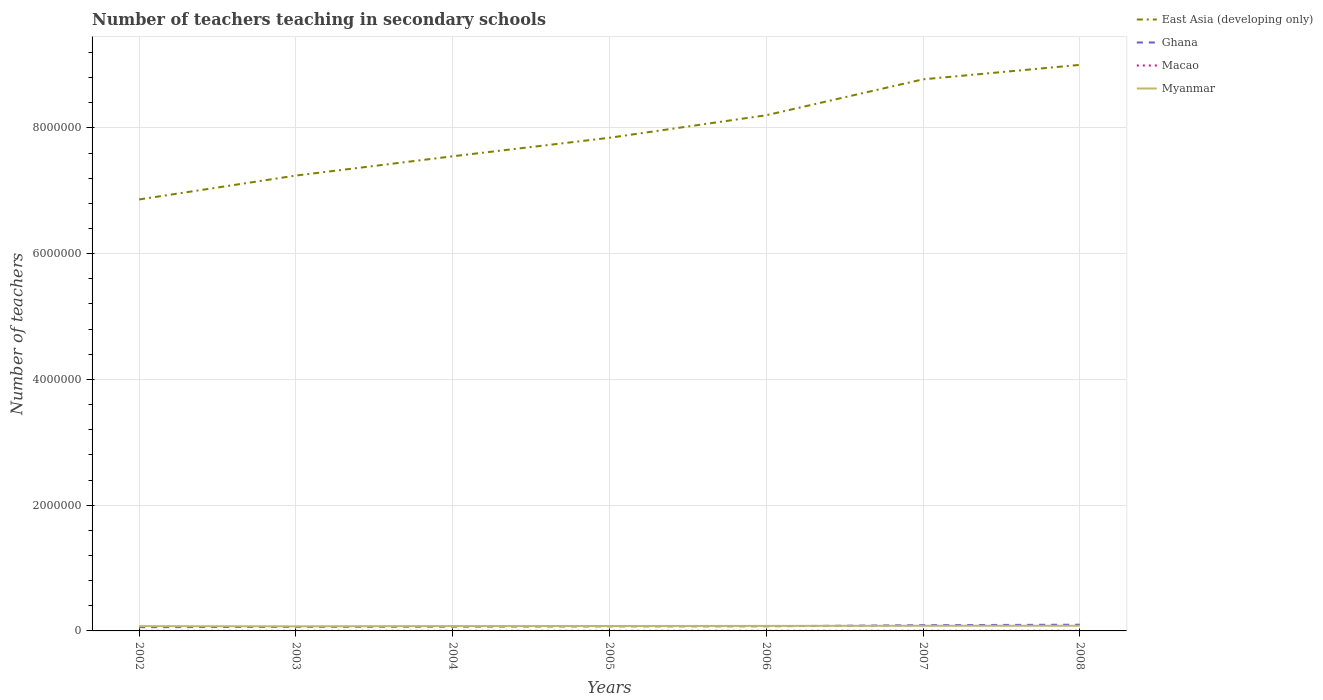Does the line corresponding to East Asia (developing only) intersect with the line corresponding to Myanmar?
Your answer should be compact. No. Is the number of lines equal to the number of legend labels?
Provide a short and direct response. Yes. Across all years, what is the maximum number of teachers teaching in secondary schools in Ghana?
Give a very brief answer. 5.94e+04. What is the total number of teachers teaching in secondary schools in East Asia (developing only) in the graph?
Provide a short and direct response. -8.01e+05. What is the difference between the highest and the second highest number of teachers teaching in secondary schools in Macao?
Offer a terse response. 457. What is the difference between the highest and the lowest number of teachers teaching in secondary schools in Macao?
Offer a very short reply. 4. Is the number of teachers teaching in secondary schools in Macao strictly greater than the number of teachers teaching in secondary schools in Myanmar over the years?
Ensure brevity in your answer.  Yes. How many lines are there?
Provide a short and direct response. 4. What is the difference between two consecutive major ticks on the Y-axis?
Make the answer very short. 2.00e+06. Does the graph contain grids?
Give a very brief answer. Yes. Where does the legend appear in the graph?
Your answer should be very brief. Top right. How many legend labels are there?
Your answer should be very brief. 4. What is the title of the graph?
Ensure brevity in your answer.  Number of teachers teaching in secondary schools. What is the label or title of the X-axis?
Your answer should be very brief. Years. What is the label or title of the Y-axis?
Offer a terse response. Number of teachers. What is the Number of teachers in East Asia (developing only) in 2002?
Your answer should be very brief. 6.86e+06. What is the Number of teachers in Ghana in 2002?
Offer a terse response. 5.94e+04. What is the Number of teachers of Macao in 2002?
Make the answer very short. 1753. What is the Number of teachers in Myanmar in 2002?
Offer a very short reply. 7.62e+04. What is the Number of teachers of East Asia (developing only) in 2003?
Provide a succinct answer. 7.24e+06. What is the Number of teachers in Ghana in 2003?
Keep it short and to the point. 6.44e+04. What is the Number of teachers in Macao in 2003?
Give a very brief answer. 1791. What is the Number of teachers in Myanmar in 2003?
Your answer should be very brief. 7.31e+04. What is the Number of teachers of East Asia (developing only) in 2004?
Make the answer very short. 7.55e+06. What is the Number of teachers of Ghana in 2004?
Ensure brevity in your answer.  6.79e+04. What is the Number of teachers in Macao in 2004?
Your answer should be very brief. 2001. What is the Number of teachers in Myanmar in 2004?
Your answer should be compact. 7.70e+04. What is the Number of teachers of East Asia (developing only) in 2005?
Keep it short and to the point. 7.84e+06. What is the Number of teachers of Ghana in 2005?
Your answer should be very brief. 7.25e+04. What is the Number of teachers of Macao in 2005?
Provide a succinct answer. 2077. What is the Number of teachers of Myanmar in 2005?
Make the answer very short. 7.81e+04. What is the Number of teachers of East Asia (developing only) in 2006?
Your response must be concise. 8.20e+06. What is the Number of teachers of Ghana in 2006?
Make the answer very short. 7.39e+04. What is the Number of teachers in Macao in 2006?
Provide a short and direct response. 2154. What is the Number of teachers in Myanmar in 2006?
Give a very brief answer. 7.98e+04. What is the Number of teachers of East Asia (developing only) in 2007?
Give a very brief answer. 8.77e+06. What is the Number of teachers in Ghana in 2007?
Make the answer very short. 9.15e+04. What is the Number of teachers of Macao in 2007?
Keep it short and to the point. 2210. What is the Number of teachers in Myanmar in 2007?
Your answer should be compact. 8.19e+04. What is the Number of teachers in East Asia (developing only) in 2008?
Provide a succinct answer. 9.00e+06. What is the Number of teachers in Ghana in 2008?
Offer a terse response. 9.90e+04. What is the Number of teachers in Macao in 2008?
Your answer should be compact. 2177. What is the Number of teachers of Myanmar in 2008?
Your answer should be very brief. 8.20e+04. Across all years, what is the maximum Number of teachers in East Asia (developing only)?
Make the answer very short. 9.00e+06. Across all years, what is the maximum Number of teachers of Ghana?
Your answer should be compact. 9.90e+04. Across all years, what is the maximum Number of teachers in Macao?
Offer a terse response. 2210. Across all years, what is the maximum Number of teachers in Myanmar?
Provide a short and direct response. 8.20e+04. Across all years, what is the minimum Number of teachers in East Asia (developing only)?
Your answer should be compact. 6.86e+06. Across all years, what is the minimum Number of teachers in Ghana?
Provide a succinct answer. 5.94e+04. Across all years, what is the minimum Number of teachers in Macao?
Provide a succinct answer. 1753. Across all years, what is the minimum Number of teachers of Myanmar?
Offer a terse response. 7.31e+04. What is the total Number of teachers of East Asia (developing only) in the graph?
Offer a terse response. 5.55e+07. What is the total Number of teachers in Ghana in the graph?
Provide a short and direct response. 5.29e+05. What is the total Number of teachers of Macao in the graph?
Provide a succinct answer. 1.42e+04. What is the total Number of teachers in Myanmar in the graph?
Offer a very short reply. 5.48e+05. What is the difference between the Number of teachers in East Asia (developing only) in 2002 and that in 2003?
Provide a short and direct response. -3.80e+05. What is the difference between the Number of teachers in Ghana in 2002 and that in 2003?
Your answer should be very brief. -4981. What is the difference between the Number of teachers in Macao in 2002 and that in 2003?
Provide a succinct answer. -38. What is the difference between the Number of teachers in Myanmar in 2002 and that in 2003?
Keep it short and to the point. 3088. What is the difference between the Number of teachers in East Asia (developing only) in 2002 and that in 2004?
Offer a very short reply. -6.86e+05. What is the difference between the Number of teachers of Ghana in 2002 and that in 2004?
Your answer should be compact. -8508. What is the difference between the Number of teachers in Macao in 2002 and that in 2004?
Offer a terse response. -248. What is the difference between the Number of teachers of Myanmar in 2002 and that in 2004?
Provide a succinct answer. -854. What is the difference between the Number of teachers in East Asia (developing only) in 2002 and that in 2005?
Provide a succinct answer. -9.81e+05. What is the difference between the Number of teachers of Ghana in 2002 and that in 2005?
Provide a succinct answer. -1.31e+04. What is the difference between the Number of teachers of Macao in 2002 and that in 2005?
Offer a terse response. -324. What is the difference between the Number of teachers of Myanmar in 2002 and that in 2005?
Provide a succinct answer. -1994. What is the difference between the Number of teachers of East Asia (developing only) in 2002 and that in 2006?
Your response must be concise. -1.34e+06. What is the difference between the Number of teachers in Ghana in 2002 and that in 2006?
Provide a short and direct response. -1.44e+04. What is the difference between the Number of teachers in Macao in 2002 and that in 2006?
Your response must be concise. -401. What is the difference between the Number of teachers in Myanmar in 2002 and that in 2006?
Provide a short and direct response. -3687. What is the difference between the Number of teachers of East Asia (developing only) in 2002 and that in 2007?
Your response must be concise. -1.91e+06. What is the difference between the Number of teachers in Ghana in 2002 and that in 2007?
Offer a terse response. -3.20e+04. What is the difference between the Number of teachers of Macao in 2002 and that in 2007?
Your answer should be very brief. -457. What is the difference between the Number of teachers of Myanmar in 2002 and that in 2007?
Provide a short and direct response. -5793. What is the difference between the Number of teachers of East Asia (developing only) in 2002 and that in 2008?
Ensure brevity in your answer.  -2.14e+06. What is the difference between the Number of teachers in Ghana in 2002 and that in 2008?
Your answer should be very brief. -3.96e+04. What is the difference between the Number of teachers of Macao in 2002 and that in 2008?
Ensure brevity in your answer.  -424. What is the difference between the Number of teachers in Myanmar in 2002 and that in 2008?
Your response must be concise. -5851. What is the difference between the Number of teachers in East Asia (developing only) in 2003 and that in 2004?
Offer a very short reply. -3.07e+05. What is the difference between the Number of teachers of Ghana in 2003 and that in 2004?
Keep it short and to the point. -3527. What is the difference between the Number of teachers of Macao in 2003 and that in 2004?
Keep it short and to the point. -210. What is the difference between the Number of teachers in Myanmar in 2003 and that in 2004?
Keep it short and to the point. -3942. What is the difference between the Number of teachers of East Asia (developing only) in 2003 and that in 2005?
Make the answer very short. -6.01e+05. What is the difference between the Number of teachers of Ghana in 2003 and that in 2005?
Your answer should be compact. -8083. What is the difference between the Number of teachers of Macao in 2003 and that in 2005?
Ensure brevity in your answer.  -286. What is the difference between the Number of teachers in Myanmar in 2003 and that in 2005?
Keep it short and to the point. -5082. What is the difference between the Number of teachers in East Asia (developing only) in 2003 and that in 2006?
Give a very brief answer. -9.59e+05. What is the difference between the Number of teachers in Ghana in 2003 and that in 2006?
Your response must be concise. -9447. What is the difference between the Number of teachers of Macao in 2003 and that in 2006?
Ensure brevity in your answer.  -363. What is the difference between the Number of teachers of Myanmar in 2003 and that in 2006?
Ensure brevity in your answer.  -6775. What is the difference between the Number of teachers in East Asia (developing only) in 2003 and that in 2007?
Make the answer very short. -1.53e+06. What is the difference between the Number of teachers of Ghana in 2003 and that in 2007?
Provide a succinct answer. -2.71e+04. What is the difference between the Number of teachers of Macao in 2003 and that in 2007?
Your answer should be very brief. -419. What is the difference between the Number of teachers in Myanmar in 2003 and that in 2007?
Make the answer very short. -8881. What is the difference between the Number of teachers of East Asia (developing only) in 2003 and that in 2008?
Provide a succinct answer. -1.76e+06. What is the difference between the Number of teachers of Ghana in 2003 and that in 2008?
Make the answer very short. -3.46e+04. What is the difference between the Number of teachers of Macao in 2003 and that in 2008?
Keep it short and to the point. -386. What is the difference between the Number of teachers of Myanmar in 2003 and that in 2008?
Offer a terse response. -8939. What is the difference between the Number of teachers in East Asia (developing only) in 2004 and that in 2005?
Provide a succinct answer. -2.94e+05. What is the difference between the Number of teachers of Ghana in 2004 and that in 2005?
Keep it short and to the point. -4556. What is the difference between the Number of teachers of Macao in 2004 and that in 2005?
Your response must be concise. -76. What is the difference between the Number of teachers of Myanmar in 2004 and that in 2005?
Ensure brevity in your answer.  -1140. What is the difference between the Number of teachers in East Asia (developing only) in 2004 and that in 2006?
Your answer should be very brief. -6.53e+05. What is the difference between the Number of teachers in Ghana in 2004 and that in 2006?
Give a very brief answer. -5920. What is the difference between the Number of teachers of Macao in 2004 and that in 2006?
Ensure brevity in your answer.  -153. What is the difference between the Number of teachers of Myanmar in 2004 and that in 2006?
Your response must be concise. -2833. What is the difference between the Number of teachers of East Asia (developing only) in 2004 and that in 2007?
Give a very brief answer. -1.22e+06. What is the difference between the Number of teachers of Ghana in 2004 and that in 2007?
Offer a terse response. -2.35e+04. What is the difference between the Number of teachers in Macao in 2004 and that in 2007?
Offer a very short reply. -209. What is the difference between the Number of teachers of Myanmar in 2004 and that in 2007?
Give a very brief answer. -4939. What is the difference between the Number of teachers in East Asia (developing only) in 2004 and that in 2008?
Your response must be concise. -1.45e+06. What is the difference between the Number of teachers in Ghana in 2004 and that in 2008?
Your answer should be very brief. -3.11e+04. What is the difference between the Number of teachers in Macao in 2004 and that in 2008?
Offer a very short reply. -176. What is the difference between the Number of teachers of Myanmar in 2004 and that in 2008?
Your response must be concise. -4997. What is the difference between the Number of teachers in East Asia (developing only) in 2005 and that in 2006?
Your answer should be compact. -3.58e+05. What is the difference between the Number of teachers of Ghana in 2005 and that in 2006?
Provide a short and direct response. -1364. What is the difference between the Number of teachers in Macao in 2005 and that in 2006?
Provide a short and direct response. -77. What is the difference between the Number of teachers in Myanmar in 2005 and that in 2006?
Offer a terse response. -1693. What is the difference between the Number of teachers in East Asia (developing only) in 2005 and that in 2007?
Keep it short and to the point. -9.29e+05. What is the difference between the Number of teachers of Ghana in 2005 and that in 2007?
Your answer should be very brief. -1.90e+04. What is the difference between the Number of teachers of Macao in 2005 and that in 2007?
Offer a terse response. -133. What is the difference between the Number of teachers of Myanmar in 2005 and that in 2007?
Give a very brief answer. -3799. What is the difference between the Number of teachers of East Asia (developing only) in 2005 and that in 2008?
Provide a succinct answer. -1.16e+06. What is the difference between the Number of teachers of Ghana in 2005 and that in 2008?
Your response must be concise. -2.65e+04. What is the difference between the Number of teachers of Macao in 2005 and that in 2008?
Give a very brief answer. -100. What is the difference between the Number of teachers in Myanmar in 2005 and that in 2008?
Make the answer very short. -3857. What is the difference between the Number of teachers of East Asia (developing only) in 2006 and that in 2007?
Provide a short and direct response. -5.71e+05. What is the difference between the Number of teachers of Ghana in 2006 and that in 2007?
Your response must be concise. -1.76e+04. What is the difference between the Number of teachers of Macao in 2006 and that in 2007?
Your response must be concise. -56. What is the difference between the Number of teachers in Myanmar in 2006 and that in 2007?
Make the answer very short. -2106. What is the difference between the Number of teachers of East Asia (developing only) in 2006 and that in 2008?
Provide a short and direct response. -8.01e+05. What is the difference between the Number of teachers of Ghana in 2006 and that in 2008?
Provide a succinct answer. -2.51e+04. What is the difference between the Number of teachers of Macao in 2006 and that in 2008?
Provide a short and direct response. -23. What is the difference between the Number of teachers in Myanmar in 2006 and that in 2008?
Your answer should be compact. -2164. What is the difference between the Number of teachers in East Asia (developing only) in 2007 and that in 2008?
Your answer should be very brief. -2.30e+05. What is the difference between the Number of teachers of Ghana in 2007 and that in 2008?
Keep it short and to the point. -7514. What is the difference between the Number of teachers of Macao in 2007 and that in 2008?
Provide a short and direct response. 33. What is the difference between the Number of teachers of Myanmar in 2007 and that in 2008?
Make the answer very short. -58. What is the difference between the Number of teachers of East Asia (developing only) in 2002 and the Number of teachers of Ghana in 2003?
Provide a succinct answer. 6.80e+06. What is the difference between the Number of teachers of East Asia (developing only) in 2002 and the Number of teachers of Macao in 2003?
Keep it short and to the point. 6.86e+06. What is the difference between the Number of teachers in East Asia (developing only) in 2002 and the Number of teachers in Myanmar in 2003?
Make the answer very short. 6.79e+06. What is the difference between the Number of teachers in Ghana in 2002 and the Number of teachers in Macao in 2003?
Your response must be concise. 5.76e+04. What is the difference between the Number of teachers of Ghana in 2002 and the Number of teachers of Myanmar in 2003?
Keep it short and to the point. -1.36e+04. What is the difference between the Number of teachers in Macao in 2002 and the Number of teachers in Myanmar in 2003?
Ensure brevity in your answer.  -7.13e+04. What is the difference between the Number of teachers in East Asia (developing only) in 2002 and the Number of teachers in Ghana in 2004?
Offer a very short reply. 6.79e+06. What is the difference between the Number of teachers of East Asia (developing only) in 2002 and the Number of teachers of Macao in 2004?
Ensure brevity in your answer.  6.86e+06. What is the difference between the Number of teachers of East Asia (developing only) in 2002 and the Number of teachers of Myanmar in 2004?
Provide a short and direct response. 6.78e+06. What is the difference between the Number of teachers in Ghana in 2002 and the Number of teachers in Macao in 2004?
Your answer should be very brief. 5.74e+04. What is the difference between the Number of teachers of Ghana in 2002 and the Number of teachers of Myanmar in 2004?
Provide a short and direct response. -1.76e+04. What is the difference between the Number of teachers in Macao in 2002 and the Number of teachers in Myanmar in 2004?
Offer a very short reply. -7.53e+04. What is the difference between the Number of teachers of East Asia (developing only) in 2002 and the Number of teachers of Ghana in 2005?
Give a very brief answer. 6.79e+06. What is the difference between the Number of teachers in East Asia (developing only) in 2002 and the Number of teachers in Macao in 2005?
Your answer should be compact. 6.86e+06. What is the difference between the Number of teachers in East Asia (developing only) in 2002 and the Number of teachers in Myanmar in 2005?
Provide a succinct answer. 6.78e+06. What is the difference between the Number of teachers of Ghana in 2002 and the Number of teachers of Macao in 2005?
Your answer should be very brief. 5.74e+04. What is the difference between the Number of teachers of Ghana in 2002 and the Number of teachers of Myanmar in 2005?
Your answer should be very brief. -1.87e+04. What is the difference between the Number of teachers of Macao in 2002 and the Number of teachers of Myanmar in 2005?
Provide a succinct answer. -7.64e+04. What is the difference between the Number of teachers of East Asia (developing only) in 2002 and the Number of teachers of Ghana in 2006?
Offer a terse response. 6.79e+06. What is the difference between the Number of teachers of East Asia (developing only) in 2002 and the Number of teachers of Macao in 2006?
Make the answer very short. 6.86e+06. What is the difference between the Number of teachers in East Asia (developing only) in 2002 and the Number of teachers in Myanmar in 2006?
Provide a short and direct response. 6.78e+06. What is the difference between the Number of teachers in Ghana in 2002 and the Number of teachers in Macao in 2006?
Your answer should be very brief. 5.73e+04. What is the difference between the Number of teachers of Ghana in 2002 and the Number of teachers of Myanmar in 2006?
Provide a short and direct response. -2.04e+04. What is the difference between the Number of teachers of Macao in 2002 and the Number of teachers of Myanmar in 2006?
Make the answer very short. -7.81e+04. What is the difference between the Number of teachers of East Asia (developing only) in 2002 and the Number of teachers of Ghana in 2007?
Provide a short and direct response. 6.77e+06. What is the difference between the Number of teachers in East Asia (developing only) in 2002 and the Number of teachers in Macao in 2007?
Make the answer very short. 6.86e+06. What is the difference between the Number of teachers of East Asia (developing only) in 2002 and the Number of teachers of Myanmar in 2007?
Provide a succinct answer. 6.78e+06. What is the difference between the Number of teachers of Ghana in 2002 and the Number of teachers of Macao in 2007?
Give a very brief answer. 5.72e+04. What is the difference between the Number of teachers in Ghana in 2002 and the Number of teachers in Myanmar in 2007?
Keep it short and to the point. -2.25e+04. What is the difference between the Number of teachers of Macao in 2002 and the Number of teachers of Myanmar in 2007?
Ensure brevity in your answer.  -8.02e+04. What is the difference between the Number of teachers of East Asia (developing only) in 2002 and the Number of teachers of Ghana in 2008?
Provide a short and direct response. 6.76e+06. What is the difference between the Number of teachers in East Asia (developing only) in 2002 and the Number of teachers in Macao in 2008?
Make the answer very short. 6.86e+06. What is the difference between the Number of teachers in East Asia (developing only) in 2002 and the Number of teachers in Myanmar in 2008?
Ensure brevity in your answer.  6.78e+06. What is the difference between the Number of teachers of Ghana in 2002 and the Number of teachers of Macao in 2008?
Provide a succinct answer. 5.73e+04. What is the difference between the Number of teachers in Ghana in 2002 and the Number of teachers in Myanmar in 2008?
Your response must be concise. -2.26e+04. What is the difference between the Number of teachers in Macao in 2002 and the Number of teachers in Myanmar in 2008?
Your answer should be very brief. -8.02e+04. What is the difference between the Number of teachers in East Asia (developing only) in 2003 and the Number of teachers in Ghana in 2004?
Provide a succinct answer. 7.17e+06. What is the difference between the Number of teachers in East Asia (developing only) in 2003 and the Number of teachers in Macao in 2004?
Your answer should be very brief. 7.24e+06. What is the difference between the Number of teachers in East Asia (developing only) in 2003 and the Number of teachers in Myanmar in 2004?
Provide a succinct answer. 7.16e+06. What is the difference between the Number of teachers in Ghana in 2003 and the Number of teachers in Macao in 2004?
Provide a short and direct response. 6.24e+04. What is the difference between the Number of teachers of Ghana in 2003 and the Number of teachers of Myanmar in 2004?
Ensure brevity in your answer.  -1.26e+04. What is the difference between the Number of teachers in Macao in 2003 and the Number of teachers in Myanmar in 2004?
Your response must be concise. -7.52e+04. What is the difference between the Number of teachers in East Asia (developing only) in 2003 and the Number of teachers in Ghana in 2005?
Your answer should be compact. 7.17e+06. What is the difference between the Number of teachers of East Asia (developing only) in 2003 and the Number of teachers of Macao in 2005?
Your response must be concise. 7.24e+06. What is the difference between the Number of teachers of East Asia (developing only) in 2003 and the Number of teachers of Myanmar in 2005?
Make the answer very short. 7.16e+06. What is the difference between the Number of teachers in Ghana in 2003 and the Number of teachers in Macao in 2005?
Provide a short and direct response. 6.23e+04. What is the difference between the Number of teachers of Ghana in 2003 and the Number of teachers of Myanmar in 2005?
Provide a succinct answer. -1.37e+04. What is the difference between the Number of teachers of Macao in 2003 and the Number of teachers of Myanmar in 2005?
Provide a short and direct response. -7.64e+04. What is the difference between the Number of teachers in East Asia (developing only) in 2003 and the Number of teachers in Ghana in 2006?
Provide a succinct answer. 7.17e+06. What is the difference between the Number of teachers in East Asia (developing only) in 2003 and the Number of teachers in Macao in 2006?
Your answer should be compact. 7.24e+06. What is the difference between the Number of teachers in East Asia (developing only) in 2003 and the Number of teachers in Myanmar in 2006?
Your response must be concise. 7.16e+06. What is the difference between the Number of teachers of Ghana in 2003 and the Number of teachers of Macao in 2006?
Your answer should be compact. 6.23e+04. What is the difference between the Number of teachers of Ghana in 2003 and the Number of teachers of Myanmar in 2006?
Offer a terse response. -1.54e+04. What is the difference between the Number of teachers in Macao in 2003 and the Number of teachers in Myanmar in 2006?
Provide a short and direct response. -7.80e+04. What is the difference between the Number of teachers in East Asia (developing only) in 2003 and the Number of teachers in Ghana in 2007?
Ensure brevity in your answer.  7.15e+06. What is the difference between the Number of teachers of East Asia (developing only) in 2003 and the Number of teachers of Macao in 2007?
Make the answer very short. 7.24e+06. What is the difference between the Number of teachers in East Asia (developing only) in 2003 and the Number of teachers in Myanmar in 2007?
Provide a succinct answer. 7.16e+06. What is the difference between the Number of teachers in Ghana in 2003 and the Number of teachers in Macao in 2007?
Your answer should be compact. 6.22e+04. What is the difference between the Number of teachers in Ghana in 2003 and the Number of teachers in Myanmar in 2007?
Provide a succinct answer. -1.75e+04. What is the difference between the Number of teachers in Macao in 2003 and the Number of teachers in Myanmar in 2007?
Offer a terse response. -8.02e+04. What is the difference between the Number of teachers in East Asia (developing only) in 2003 and the Number of teachers in Ghana in 2008?
Offer a terse response. 7.14e+06. What is the difference between the Number of teachers in East Asia (developing only) in 2003 and the Number of teachers in Macao in 2008?
Give a very brief answer. 7.24e+06. What is the difference between the Number of teachers in East Asia (developing only) in 2003 and the Number of teachers in Myanmar in 2008?
Offer a terse response. 7.16e+06. What is the difference between the Number of teachers in Ghana in 2003 and the Number of teachers in Macao in 2008?
Keep it short and to the point. 6.22e+04. What is the difference between the Number of teachers in Ghana in 2003 and the Number of teachers in Myanmar in 2008?
Provide a succinct answer. -1.76e+04. What is the difference between the Number of teachers of Macao in 2003 and the Number of teachers of Myanmar in 2008?
Ensure brevity in your answer.  -8.02e+04. What is the difference between the Number of teachers in East Asia (developing only) in 2004 and the Number of teachers in Ghana in 2005?
Offer a very short reply. 7.48e+06. What is the difference between the Number of teachers of East Asia (developing only) in 2004 and the Number of teachers of Macao in 2005?
Provide a short and direct response. 7.55e+06. What is the difference between the Number of teachers of East Asia (developing only) in 2004 and the Number of teachers of Myanmar in 2005?
Your response must be concise. 7.47e+06. What is the difference between the Number of teachers in Ghana in 2004 and the Number of teachers in Macao in 2005?
Your answer should be compact. 6.59e+04. What is the difference between the Number of teachers of Ghana in 2004 and the Number of teachers of Myanmar in 2005?
Offer a very short reply. -1.02e+04. What is the difference between the Number of teachers of Macao in 2004 and the Number of teachers of Myanmar in 2005?
Ensure brevity in your answer.  -7.61e+04. What is the difference between the Number of teachers in East Asia (developing only) in 2004 and the Number of teachers in Ghana in 2006?
Make the answer very short. 7.47e+06. What is the difference between the Number of teachers of East Asia (developing only) in 2004 and the Number of teachers of Macao in 2006?
Provide a short and direct response. 7.55e+06. What is the difference between the Number of teachers of East Asia (developing only) in 2004 and the Number of teachers of Myanmar in 2006?
Keep it short and to the point. 7.47e+06. What is the difference between the Number of teachers in Ghana in 2004 and the Number of teachers in Macao in 2006?
Your answer should be compact. 6.58e+04. What is the difference between the Number of teachers of Ghana in 2004 and the Number of teachers of Myanmar in 2006?
Keep it short and to the point. -1.19e+04. What is the difference between the Number of teachers in Macao in 2004 and the Number of teachers in Myanmar in 2006?
Provide a short and direct response. -7.78e+04. What is the difference between the Number of teachers in East Asia (developing only) in 2004 and the Number of teachers in Ghana in 2007?
Your answer should be compact. 7.46e+06. What is the difference between the Number of teachers in East Asia (developing only) in 2004 and the Number of teachers in Macao in 2007?
Offer a terse response. 7.55e+06. What is the difference between the Number of teachers in East Asia (developing only) in 2004 and the Number of teachers in Myanmar in 2007?
Make the answer very short. 7.47e+06. What is the difference between the Number of teachers in Ghana in 2004 and the Number of teachers in Macao in 2007?
Your answer should be very brief. 6.57e+04. What is the difference between the Number of teachers of Ghana in 2004 and the Number of teachers of Myanmar in 2007?
Your answer should be very brief. -1.40e+04. What is the difference between the Number of teachers in Macao in 2004 and the Number of teachers in Myanmar in 2007?
Your answer should be compact. -7.99e+04. What is the difference between the Number of teachers of East Asia (developing only) in 2004 and the Number of teachers of Ghana in 2008?
Ensure brevity in your answer.  7.45e+06. What is the difference between the Number of teachers of East Asia (developing only) in 2004 and the Number of teachers of Macao in 2008?
Your answer should be compact. 7.55e+06. What is the difference between the Number of teachers in East Asia (developing only) in 2004 and the Number of teachers in Myanmar in 2008?
Provide a succinct answer. 7.47e+06. What is the difference between the Number of teachers in Ghana in 2004 and the Number of teachers in Macao in 2008?
Keep it short and to the point. 6.58e+04. What is the difference between the Number of teachers of Ghana in 2004 and the Number of teachers of Myanmar in 2008?
Your answer should be compact. -1.41e+04. What is the difference between the Number of teachers in East Asia (developing only) in 2005 and the Number of teachers in Ghana in 2006?
Your answer should be very brief. 7.77e+06. What is the difference between the Number of teachers in East Asia (developing only) in 2005 and the Number of teachers in Macao in 2006?
Make the answer very short. 7.84e+06. What is the difference between the Number of teachers of East Asia (developing only) in 2005 and the Number of teachers of Myanmar in 2006?
Ensure brevity in your answer.  7.76e+06. What is the difference between the Number of teachers in Ghana in 2005 and the Number of teachers in Macao in 2006?
Ensure brevity in your answer.  7.03e+04. What is the difference between the Number of teachers of Ghana in 2005 and the Number of teachers of Myanmar in 2006?
Offer a terse response. -7335. What is the difference between the Number of teachers of Macao in 2005 and the Number of teachers of Myanmar in 2006?
Make the answer very short. -7.78e+04. What is the difference between the Number of teachers of East Asia (developing only) in 2005 and the Number of teachers of Ghana in 2007?
Provide a short and direct response. 7.75e+06. What is the difference between the Number of teachers in East Asia (developing only) in 2005 and the Number of teachers in Macao in 2007?
Ensure brevity in your answer.  7.84e+06. What is the difference between the Number of teachers of East Asia (developing only) in 2005 and the Number of teachers of Myanmar in 2007?
Provide a short and direct response. 7.76e+06. What is the difference between the Number of teachers of Ghana in 2005 and the Number of teachers of Macao in 2007?
Provide a short and direct response. 7.03e+04. What is the difference between the Number of teachers in Ghana in 2005 and the Number of teachers in Myanmar in 2007?
Ensure brevity in your answer.  -9441. What is the difference between the Number of teachers in Macao in 2005 and the Number of teachers in Myanmar in 2007?
Provide a succinct answer. -7.99e+04. What is the difference between the Number of teachers in East Asia (developing only) in 2005 and the Number of teachers in Ghana in 2008?
Your answer should be very brief. 7.74e+06. What is the difference between the Number of teachers in East Asia (developing only) in 2005 and the Number of teachers in Macao in 2008?
Make the answer very short. 7.84e+06. What is the difference between the Number of teachers of East Asia (developing only) in 2005 and the Number of teachers of Myanmar in 2008?
Make the answer very short. 7.76e+06. What is the difference between the Number of teachers in Ghana in 2005 and the Number of teachers in Macao in 2008?
Your answer should be very brief. 7.03e+04. What is the difference between the Number of teachers in Ghana in 2005 and the Number of teachers in Myanmar in 2008?
Your answer should be very brief. -9499. What is the difference between the Number of teachers of Macao in 2005 and the Number of teachers of Myanmar in 2008?
Offer a very short reply. -7.99e+04. What is the difference between the Number of teachers of East Asia (developing only) in 2006 and the Number of teachers of Ghana in 2007?
Provide a short and direct response. 8.11e+06. What is the difference between the Number of teachers of East Asia (developing only) in 2006 and the Number of teachers of Macao in 2007?
Offer a terse response. 8.20e+06. What is the difference between the Number of teachers of East Asia (developing only) in 2006 and the Number of teachers of Myanmar in 2007?
Offer a very short reply. 8.12e+06. What is the difference between the Number of teachers of Ghana in 2006 and the Number of teachers of Macao in 2007?
Your answer should be very brief. 7.17e+04. What is the difference between the Number of teachers of Ghana in 2006 and the Number of teachers of Myanmar in 2007?
Offer a very short reply. -8077. What is the difference between the Number of teachers of Macao in 2006 and the Number of teachers of Myanmar in 2007?
Make the answer very short. -7.98e+04. What is the difference between the Number of teachers of East Asia (developing only) in 2006 and the Number of teachers of Ghana in 2008?
Ensure brevity in your answer.  8.10e+06. What is the difference between the Number of teachers of East Asia (developing only) in 2006 and the Number of teachers of Macao in 2008?
Make the answer very short. 8.20e+06. What is the difference between the Number of teachers of East Asia (developing only) in 2006 and the Number of teachers of Myanmar in 2008?
Your answer should be very brief. 8.12e+06. What is the difference between the Number of teachers in Ghana in 2006 and the Number of teachers in Macao in 2008?
Your answer should be compact. 7.17e+04. What is the difference between the Number of teachers in Ghana in 2006 and the Number of teachers in Myanmar in 2008?
Provide a succinct answer. -8135. What is the difference between the Number of teachers in Macao in 2006 and the Number of teachers in Myanmar in 2008?
Offer a terse response. -7.98e+04. What is the difference between the Number of teachers of East Asia (developing only) in 2007 and the Number of teachers of Ghana in 2008?
Your answer should be very brief. 8.67e+06. What is the difference between the Number of teachers in East Asia (developing only) in 2007 and the Number of teachers in Macao in 2008?
Provide a succinct answer. 8.77e+06. What is the difference between the Number of teachers in East Asia (developing only) in 2007 and the Number of teachers in Myanmar in 2008?
Provide a short and direct response. 8.69e+06. What is the difference between the Number of teachers of Ghana in 2007 and the Number of teachers of Macao in 2008?
Your answer should be compact. 8.93e+04. What is the difference between the Number of teachers in Ghana in 2007 and the Number of teachers in Myanmar in 2008?
Keep it short and to the point. 9486. What is the difference between the Number of teachers in Macao in 2007 and the Number of teachers in Myanmar in 2008?
Provide a short and direct response. -7.98e+04. What is the average Number of teachers of East Asia (developing only) per year?
Keep it short and to the point. 7.92e+06. What is the average Number of teachers of Ghana per year?
Ensure brevity in your answer.  7.55e+04. What is the average Number of teachers of Macao per year?
Give a very brief answer. 2023.29. What is the average Number of teachers of Myanmar per year?
Your answer should be compact. 7.83e+04. In the year 2002, what is the difference between the Number of teachers in East Asia (developing only) and Number of teachers in Ghana?
Offer a very short reply. 6.80e+06. In the year 2002, what is the difference between the Number of teachers of East Asia (developing only) and Number of teachers of Macao?
Give a very brief answer. 6.86e+06. In the year 2002, what is the difference between the Number of teachers of East Asia (developing only) and Number of teachers of Myanmar?
Your answer should be very brief. 6.79e+06. In the year 2002, what is the difference between the Number of teachers in Ghana and Number of teachers in Macao?
Your answer should be compact. 5.77e+04. In the year 2002, what is the difference between the Number of teachers of Ghana and Number of teachers of Myanmar?
Offer a very short reply. -1.67e+04. In the year 2002, what is the difference between the Number of teachers of Macao and Number of teachers of Myanmar?
Your response must be concise. -7.44e+04. In the year 2003, what is the difference between the Number of teachers in East Asia (developing only) and Number of teachers in Ghana?
Offer a terse response. 7.18e+06. In the year 2003, what is the difference between the Number of teachers of East Asia (developing only) and Number of teachers of Macao?
Offer a terse response. 7.24e+06. In the year 2003, what is the difference between the Number of teachers in East Asia (developing only) and Number of teachers in Myanmar?
Offer a very short reply. 7.17e+06. In the year 2003, what is the difference between the Number of teachers of Ghana and Number of teachers of Macao?
Offer a terse response. 6.26e+04. In the year 2003, what is the difference between the Number of teachers in Ghana and Number of teachers in Myanmar?
Keep it short and to the point. -8643. In the year 2003, what is the difference between the Number of teachers of Macao and Number of teachers of Myanmar?
Provide a short and direct response. -7.13e+04. In the year 2004, what is the difference between the Number of teachers of East Asia (developing only) and Number of teachers of Ghana?
Offer a terse response. 7.48e+06. In the year 2004, what is the difference between the Number of teachers in East Asia (developing only) and Number of teachers in Macao?
Ensure brevity in your answer.  7.55e+06. In the year 2004, what is the difference between the Number of teachers of East Asia (developing only) and Number of teachers of Myanmar?
Offer a terse response. 7.47e+06. In the year 2004, what is the difference between the Number of teachers in Ghana and Number of teachers in Macao?
Your response must be concise. 6.59e+04. In the year 2004, what is the difference between the Number of teachers in Ghana and Number of teachers in Myanmar?
Offer a terse response. -9058. In the year 2004, what is the difference between the Number of teachers in Macao and Number of teachers in Myanmar?
Provide a short and direct response. -7.50e+04. In the year 2005, what is the difference between the Number of teachers of East Asia (developing only) and Number of teachers of Ghana?
Ensure brevity in your answer.  7.77e+06. In the year 2005, what is the difference between the Number of teachers of East Asia (developing only) and Number of teachers of Macao?
Make the answer very short. 7.84e+06. In the year 2005, what is the difference between the Number of teachers in East Asia (developing only) and Number of teachers in Myanmar?
Provide a succinct answer. 7.76e+06. In the year 2005, what is the difference between the Number of teachers of Ghana and Number of teachers of Macao?
Your answer should be very brief. 7.04e+04. In the year 2005, what is the difference between the Number of teachers of Ghana and Number of teachers of Myanmar?
Offer a very short reply. -5642. In the year 2005, what is the difference between the Number of teachers of Macao and Number of teachers of Myanmar?
Make the answer very short. -7.61e+04. In the year 2006, what is the difference between the Number of teachers of East Asia (developing only) and Number of teachers of Ghana?
Provide a short and direct response. 8.13e+06. In the year 2006, what is the difference between the Number of teachers in East Asia (developing only) and Number of teachers in Macao?
Give a very brief answer. 8.20e+06. In the year 2006, what is the difference between the Number of teachers of East Asia (developing only) and Number of teachers of Myanmar?
Provide a succinct answer. 8.12e+06. In the year 2006, what is the difference between the Number of teachers in Ghana and Number of teachers in Macao?
Offer a very short reply. 7.17e+04. In the year 2006, what is the difference between the Number of teachers of Ghana and Number of teachers of Myanmar?
Give a very brief answer. -5971. In the year 2006, what is the difference between the Number of teachers of Macao and Number of teachers of Myanmar?
Offer a very short reply. -7.77e+04. In the year 2007, what is the difference between the Number of teachers in East Asia (developing only) and Number of teachers in Ghana?
Offer a very short reply. 8.68e+06. In the year 2007, what is the difference between the Number of teachers of East Asia (developing only) and Number of teachers of Macao?
Keep it short and to the point. 8.77e+06. In the year 2007, what is the difference between the Number of teachers of East Asia (developing only) and Number of teachers of Myanmar?
Offer a terse response. 8.69e+06. In the year 2007, what is the difference between the Number of teachers of Ghana and Number of teachers of Macao?
Ensure brevity in your answer.  8.93e+04. In the year 2007, what is the difference between the Number of teachers in Ghana and Number of teachers in Myanmar?
Offer a terse response. 9544. In the year 2007, what is the difference between the Number of teachers of Macao and Number of teachers of Myanmar?
Ensure brevity in your answer.  -7.97e+04. In the year 2008, what is the difference between the Number of teachers in East Asia (developing only) and Number of teachers in Ghana?
Your response must be concise. 8.90e+06. In the year 2008, what is the difference between the Number of teachers of East Asia (developing only) and Number of teachers of Macao?
Make the answer very short. 9.00e+06. In the year 2008, what is the difference between the Number of teachers in East Asia (developing only) and Number of teachers in Myanmar?
Offer a terse response. 8.92e+06. In the year 2008, what is the difference between the Number of teachers of Ghana and Number of teachers of Macao?
Offer a terse response. 9.68e+04. In the year 2008, what is the difference between the Number of teachers of Ghana and Number of teachers of Myanmar?
Make the answer very short. 1.70e+04. In the year 2008, what is the difference between the Number of teachers of Macao and Number of teachers of Myanmar?
Offer a very short reply. -7.98e+04. What is the ratio of the Number of teachers of East Asia (developing only) in 2002 to that in 2003?
Provide a succinct answer. 0.95. What is the ratio of the Number of teachers in Ghana in 2002 to that in 2003?
Provide a succinct answer. 0.92. What is the ratio of the Number of teachers of Macao in 2002 to that in 2003?
Offer a terse response. 0.98. What is the ratio of the Number of teachers of Myanmar in 2002 to that in 2003?
Keep it short and to the point. 1.04. What is the ratio of the Number of teachers in Ghana in 2002 to that in 2004?
Ensure brevity in your answer.  0.87. What is the ratio of the Number of teachers of Macao in 2002 to that in 2004?
Your answer should be compact. 0.88. What is the ratio of the Number of teachers in Myanmar in 2002 to that in 2004?
Offer a terse response. 0.99. What is the ratio of the Number of teachers of East Asia (developing only) in 2002 to that in 2005?
Provide a succinct answer. 0.87. What is the ratio of the Number of teachers in Ghana in 2002 to that in 2005?
Offer a very short reply. 0.82. What is the ratio of the Number of teachers in Macao in 2002 to that in 2005?
Your answer should be very brief. 0.84. What is the ratio of the Number of teachers in Myanmar in 2002 to that in 2005?
Provide a succinct answer. 0.97. What is the ratio of the Number of teachers in East Asia (developing only) in 2002 to that in 2006?
Make the answer very short. 0.84. What is the ratio of the Number of teachers in Ghana in 2002 to that in 2006?
Ensure brevity in your answer.  0.8. What is the ratio of the Number of teachers in Macao in 2002 to that in 2006?
Offer a terse response. 0.81. What is the ratio of the Number of teachers in Myanmar in 2002 to that in 2006?
Your response must be concise. 0.95. What is the ratio of the Number of teachers in East Asia (developing only) in 2002 to that in 2007?
Your response must be concise. 0.78. What is the ratio of the Number of teachers in Ghana in 2002 to that in 2007?
Provide a short and direct response. 0.65. What is the ratio of the Number of teachers of Macao in 2002 to that in 2007?
Keep it short and to the point. 0.79. What is the ratio of the Number of teachers of Myanmar in 2002 to that in 2007?
Give a very brief answer. 0.93. What is the ratio of the Number of teachers of East Asia (developing only) in 2002 to that in 2008?
Your response must be concise. 0.76. What is the ratio of the Number of teachers in Ghana in 2002 to that in 2008?
Keep it short and to the point. 0.6. What is the ratio of the Number of teachers in Macao in 2002 to that in 2008?
Your answer should be compact. 0.81. What is the ratio of the Number of teachers of East Asia (developing only) in 2003 to that in 2004?
Provide a short and direct response. 0.96. What is the ratio of the Number of teachers in Ghana in 2003 to that in 2004?
Your response must be concise. 0.95. What is the ratio of the Number of teachers in Macao in 2003 to that in 2004?
Your response must be concise. 0.9. What is the ratio of the Number of teachers of Myanmar in 2003 to that in 2004?
Your answer should be very brief. 0.95. What is the ratio of the Number of teachers in East Asia (developing only) in 2003 to that in 2005?
Give a very brief answer. 0.92. What is the ratio of the Number of teachers in Ghana in 2003 to that in 2005?
Offer a very short reply. 0.89. What is the ratio of the Number of teachers of Macao in 2003 to that in 2005?
Ensure brevity in your answer.  0.86. What is the ratio of the Number of teachers in Myanmar in 2003 to that in 2005?
Make the answer very short. 0.94. What is the ratio of the Number of teachers in East Asia (developing only) in 2003 to that in 2006?
Provide a succinct answer. 0.88. What is the ratio of the Number of teachers in Ghana in 2003 to that in 2006?
Your answer should be compact. 0.87. What is the ratio of the Number of teachers of Macao in 2003 to that in 2006?
Keep it short and to the point. 0.83. What is the ratio of the Number of teachers in Myanmar in 2003 to that in 2006?
Make the answer very short. 0.92. What is the ratio of the Number of teachers of East Asia (developing only) in 2003 to that in 2007?
Provide a succinct answer. 0.83. What is the ratio of the Number of teachers of Ghana in 2003 to that in 2007?
Keep it short and to the point. 0.7. What is the ratio of the Number of teachers in Macao in 2003 to that in 2007?
Your response must be concise. 0.81. What is the ratio of the Number of teachers of Myanmar in 2003 to that in 2007?
Your response must be concise. 0.89. What is the ratio of the Number of teachers in East Asia (developing only) in 2003 to that in 2008?
Your response must be concise. 0.8. What is the ratio of the Number of teachers of Ghana in 2003 to that in 2008?
Your response must be concise. 0.65. What is the ratio of the Number of teachers of Macao in 2003 to that in 2008?
Provide a succinct answer. 0.82. What is the ratio of the Number of teachers in Myanmar in 2003 to that in 2008?
Provide a succinct answer. 0.89. What is the ratio of the Number of teachers of East Asia (developing only) in 2004 to that in 2005?
Offer a very short reply. 0.96. What is the ratio of the Number of teachers in Ghana in 2004 to that in 2005?
Provide a succinct answer. 0.94. What is the ratio of the Number of teachers in Macao in 2004 to that in 2005?
Offer a very short reply. 0.96. What is the ratio of the Number of teachers of Myanmar in 2004 to that in 2005?
Offer a terse response. 0.99. What is the ratio of the Number of teachers of East Asia (developing only) in 2004 to that in 2006?
Offer a terse response. 0.92. What is the ratio of the Number of teachers in Ghana in 2004 to that in 2006?
Keep it short and to the point. 0.92. What is the ratio of the Number of teachers in Macao in 2004 to that in 2006?
Your response must be concise. 0.93. What is the ratio of the Number of teachers of Myanmar in 2004 to that in 2006?
Provide a succinct answer. 0.96. What is the ratio of the Number of teachers in East Asia (developing only) in 2004 to that in 2007?
Ensure brevity in your answer.  0.86. What is the ratio of the Number of teachers of Ghana in 2004 to that in 2007?
Provide a succinct answer. 0.74. What is the ratio of the Number of teachers of Macao in 2004 to that in 2007?
Make the answer very short. 0.91. What is the ratio of the Number of teachers in Myanmar in 2004 to that in 2007?
Your answer should be very brief. 0.94. What is the ratio of the Number of teachers of East Asia (developing only) in 2004 to that in 2008?
Your answer should be very brief. 0.84. What is the ratio of the Number of teachers in Ghana in 2004 to that in 2008?
Provide a short and direct response. 0.69. What is the ratio of the Number of teachers in Macao in 2004 to that in 2008?
Give a very brief answer. 0.92. What is the ratio of the Number of teachers in Myanmar in 2004 to that in 2008?
Keep it short and to the point. 0.94. What is the ratio of the Number of teachers in East Asia (developing only) in 2005 to that in 2006?
Provide a succinct answer. 0.96. What is the ratio of the Number of teachers in Ghana in 2005 to that in 2006?
Your answer should be compact. 0.98. What is the ratio of the Number of teachers in Macao in 2005 to that in 2006?
Keep it short and to the point. 0.96. What is the ratio of the Number of teachers in Myanmar in 2005 to that in 2006?
Make the answer very short. 0.98. What is the ratio of the Number of teachers of East Asia (developing only) in 2005 to that in 2007?
Keep it short and to the point. 0.89. What is the ratio of the Number of teachers of Ghana in 2005 to that in 2007?
Offer a terse response. 0.79. What is the ratio of the Number of teachers of Macao in 2005 to that in 2007?
Give a very brief answer. 0.94. What is the ratio of the Number of teachers of Myanmar in 2005 to that in 2007?
Your answer should be compact. 0.95. What is the ratio of the Number of teachers of East Asia (developing only) in 2005 to that in 2008?
Your response must be concise. 0.87. What is the ratio of the Number of teachers of Ghana in 2005 to that in 2008?
Keep it short and to the point. 0.73. What is the ratio of the Number of teachers of Macao in 2005 to that in 2008?
Give a very brief answer. 0.95. What is the ratio of the Number of teachers in Myanmar in 2005 to that in 2008?
Make the answer very short. 0.95. What is the ratio of the Number of teachers of East Asia (developing only) in 2006 to that in 2007?
Ensure brevity in your answer.  0.93. What is the ratio of the Number of teachers in Ghana in 2006 to that in 2007?
Your response must be concise. 0.81. What is the ratio of the Number of teachers in Macao in 2006 to that in 2007?
Your response must be concise. 0.97. What is the ratio of the Number of teachers of Myanmar in 2006 to that in 2007?
Ensure brevity in your answer.  0.97. What is the ratio of the Number of teachers in East Asia (developing only) in 2006 to that in 2008?
Provide a succinct answer. 0.91. What is the ratio of the Number of teachers in Ghana in 2006 to that in 2008?
Your response must be concise. 0.75. What is the ratio of the Number of teachers in Macao in 2006 to that in 2008?
Keep it short and to the point. 0.99. What is the ratio of the Number of teachers of Myanmar in 2006 to that in 2008?
Offer a terse response. 0.97. What is the ratio of the Number of teachers of East Asia (developing only) in 2007 to that in 2008?
Provide a short and direct response. 0.97. What is the ratio of the Number of teachers of Ghana in 2007 to that in 2008?
Your response must be concise. 0.92. What is the ratio of the Number of teachers in Macao in 2007 to that in 2008?
Provide a succinct answer. 1.02. What is the ratio of the Number of teachers in Myanmar in 2007 to that in 2008?
Provide a succinct answer. 1. What is the difference between the highest and the second highest Number of teachers in East Asia (developing only)?
Provide a succinct answer. 2.30e+05. What is the difference between the highest and the second highest Number of teachers of Ghana?
Offer a very short reply. 7514. What is the difference between the highest and the lowest Number of teachers in East Asia (developing only)?
Provide a succinct answer. 2.14e+06. What is the difference between the highest and the lowest Number of teachers of Ghana?
Offer a very short reply. 3.96e+04. What is the difference between the highest and the lowest Number of teachers in Macao?
Offer a terse response. 457. What is the difference between the highest and the lowest Number of teachers of Myanmar?
Provide a short and direct response. 8939. 